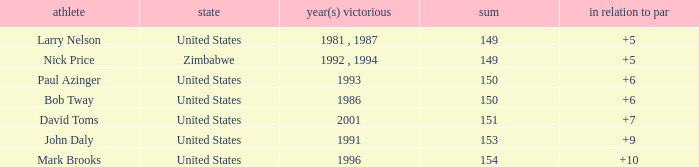What is Zimbabwe's total with a to par higher than 5? None. 